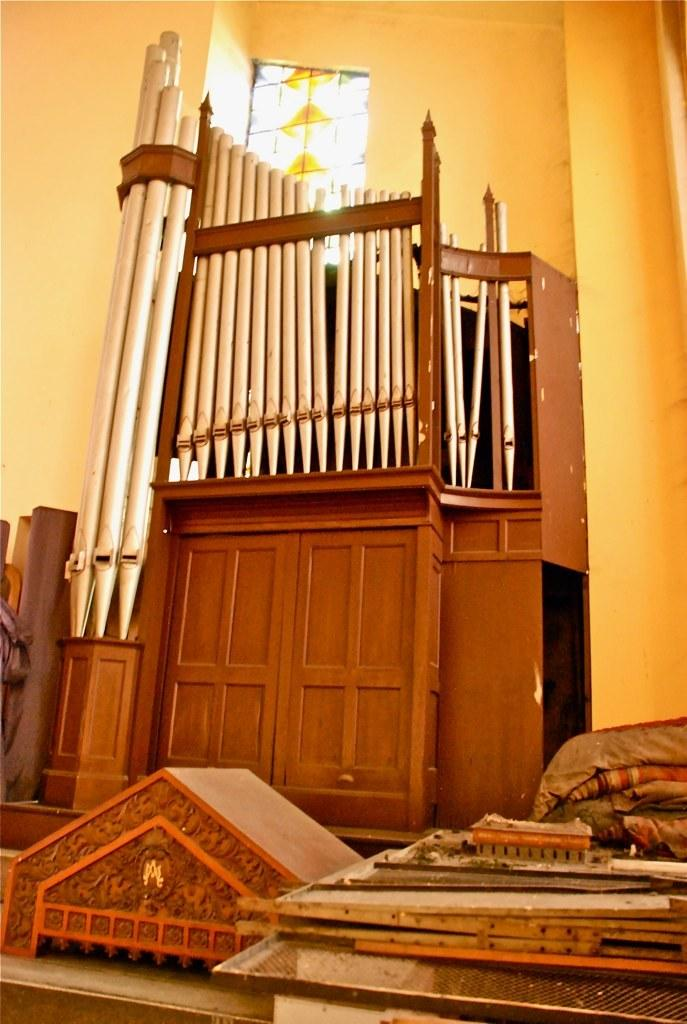What is the main structure in the center of the image? There is a wooden door in the center of the image. What type of material is used for the structure at the bottom side of the image? There are wooden boards at the bottom side of the image. What can be seen at the top side of the image? There is a window at the top side of the image. What discovery was made by the force of the spark in the image? There is no discovery, spark, or force present in the image. 